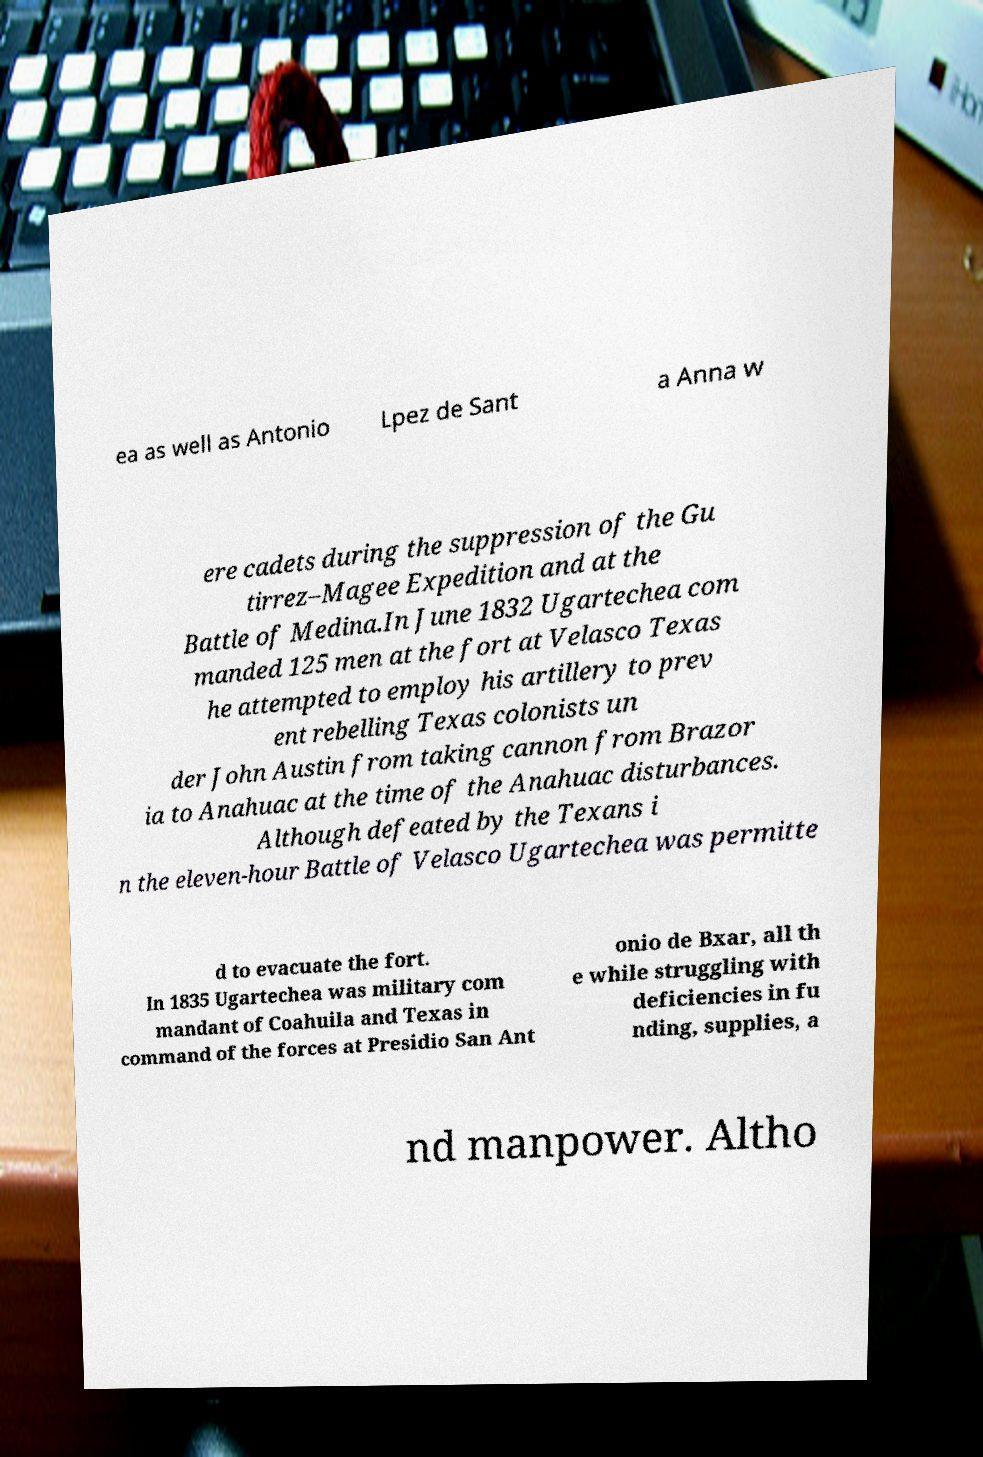Please identify and transcribe the text found in this image. ea as well as Antonio Lpez de Sant a Anna w ere cadets during the suppression of the Gu tirrez–Magee Expedition and at the Battle of Medina.In June 1832 Ugartechea com manded 125 men at the fort at Velasco Texas he attempted to employ his artillery to prev ent rebelling Texas colonists un der John Austin from taking cannon from Brazor ia to Anahuac at the time of the Anahuac disturbances. Although defeated by the Texans i n the eleven-hour Battle of Velasco Ugartechea was permitte d to evacuate the fort. In 1835 Ugartechea was military com mandant of Coahuila and Texas in command of the forces at Presidio San Ant onio de Bxar, all th e while struggling with deficiencies in fu nding, supplies, a nd manpower. Altho 